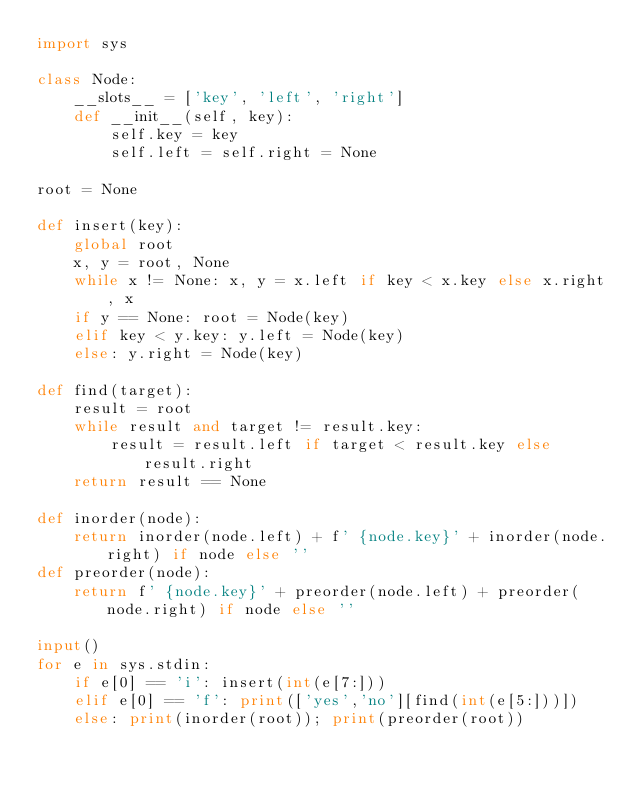<code> <loc_0><loc_0><loc_500><loc_500><_Python_>import sys

class Node:
    __slots__ = ['key', 'left', 'right']
    def __init__(self, key):
        self.key = key
        self.left = self.right = None

root = None

def insert(key):
    global root
    x, y = root, None
    while x != None: x, y = x.left if key < x.key else x.right, x
    if y == None: root = Node(key)
    elif key < y.key: y.left = Node(key)
    else: y.right = Node(key)

def find(target):
    result = root
    while result and target != result.key:
        result = result.left if target < result.key else result.right
    return result == None

def inorder(node):
    return inorder(node.left) + f' {node.key}' + inorder(node.right) if node else ''
def preorder(node):
    return f' {node.key}' + preorder(node.left) + preorder(node.right) if node else ''

input()
for e in sys.stdin:
    if e[0] == 'i': insert(int(e[7:]))
    elif e[0] == 'f': print(['yes','no'][find(int(e[5:]))])
    else: print(inorder(root)); print(preorder(root))
</code> 